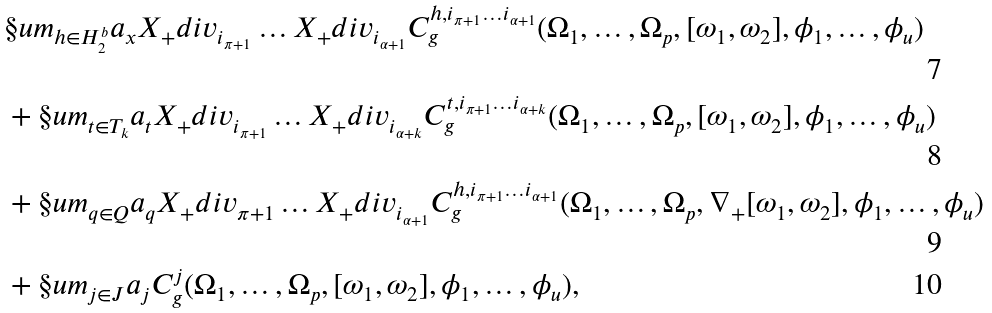<formula> <loc_0><loc_0><loc_500><loc_500>& \S u m _ { h \in H ^ { b } _ { 2 } } a _ { x } X _ { + } d i v _ { i _ { \pi + 1 } } \dots X _ { + } d i v _ { i _ { \alpha + 1 } } C ^ { h , i _ { \pi + 1 } \dots i _ { \alpha + 1 } } _ { g } ( \Omega _ { 1 } , \dots , \Omega _ { p } , [ \omega _ { 1 } , \omega _ { 2 } ] , \phi _ { 1 } , \dots , \phi _ { u } ) \\ & + \S u m _ { t \in T _ { k } } a _ { t } X _ { + } d i v _ { i _ { \pi + 1 } } \dots X _ { + } d i v _ { i _ { \alpha + k } } C ^ { t , i _ { \pi + 1 } \dots i _ { \alpha + k } } _ { g } ( \Omega _ { 1 } , \dots , \Omega _ { p } , [ \omega _ { 1 } , \omega _ { 2 } ] , \phi _ { 1 } , \dots , \phi _ { u } ) \\ & + \S u m _ { q \in Q } a _ { q } X _ { + } d i v _ { \pi + 1 } \dots X _ { + } d i v _ { i _ { \alpha + 1 } } C ^ { h , i _ { \pi + 1 } \dots i _ { \alpha + 1 } } _ { g } ( \Omega _ { 1 } , \dots , \Omega _ { p } , \nabla _ { + } [ \omega _ { 1 } , \omega _ { 2 } ] , \phi _ { 1 } , \dots , \phi _ { u } ) \\ & + \S u m _ { j \in J } a _ { j } C ^ { j } _ { g } ( \Omega _ { 1 } , \dots , \Omega _ { p } , [ \omega _ { 1 } , \omega _ { 2 } ] , \phi _ { 1 } , \dots , \phi _ { u } ) ,</formula> 